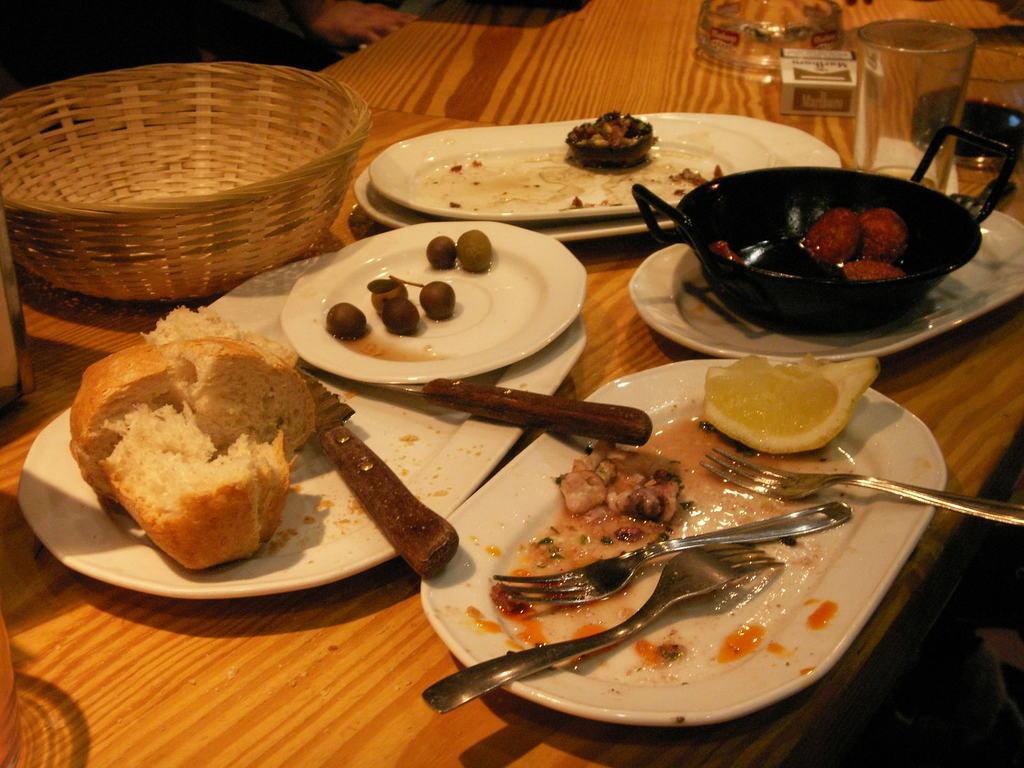How would you summarize this image in a sentence or two? In this picture there is some food, bread with knife and fork in the white plates placed on the table top. On the left side there is a wooden basket on the table. 